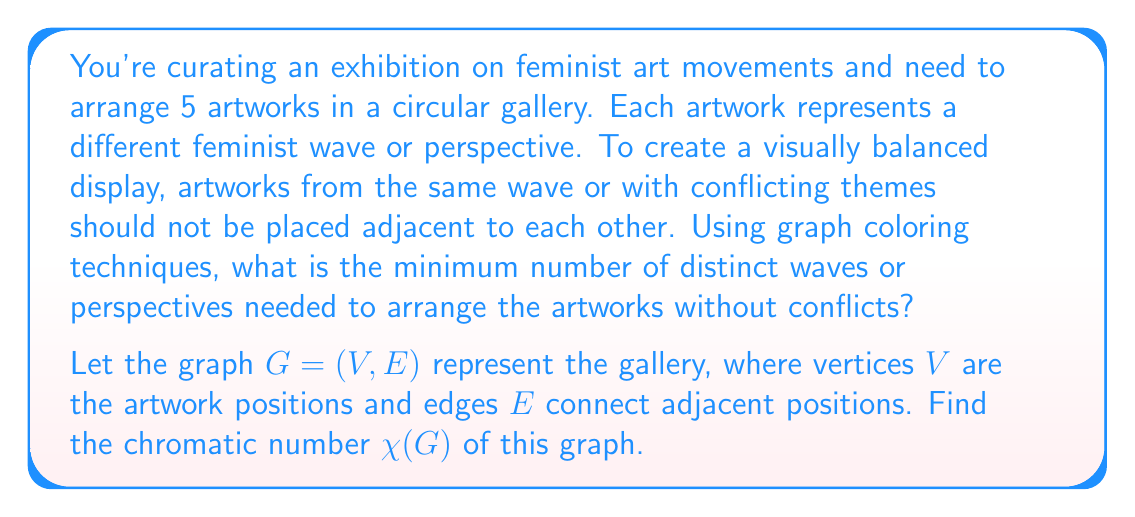Provide a solution to this math problem. To solve this problem, we'll use graph coloring techniques:

1. First, we need to visualize the gallery layout as a graph:
   [asy]
   unitsize(2cm);
   pair[] A = {dir(90), dir(162), dir(234), dir(306), dir(18)};
   for(int i=0; i<5; ++i) {
     draw(A[i]--A[(i+1)%5], black);
     dot(A[i], black);
   }
   [/asy]

2. This graph is a cycle graph with 5 vertices, denoted as $C_5$.

3. For cycle graphs:
   - If $n$ is odd, $\chi(C_n) = 3$
   - If $n$ is even, $\chi(C_n) = 2$

4. In our case, $n = 5$, which is odd.

5. Therefore, the chromatic number $\chi(C_5) = 3$.

This means we need a minimum of 3 distinct colors (representing waves or perspectives) to color the vertices such that no adjacent vertices have the same color.

In the context of the gallery, this implies that we need at least 3 different feminist waves or perspectives to arrange the artworks without conflicts.

This arrangement could represent, for example:
- First-wave feminism (e.g., suffrage movement)
- Second-wave feminism (e.g., reproductive rights)
- Third-wave feminism (e.g., intersectionality)

By using these three distinct perspectives, we can ensure a visually balanced and thematically diverse exhibition that showcases the evolution of feminist art movements.
Answer: The minimum number of distinct waves or perspectives needed is 3, as $\chi(C_5) = 3$. 